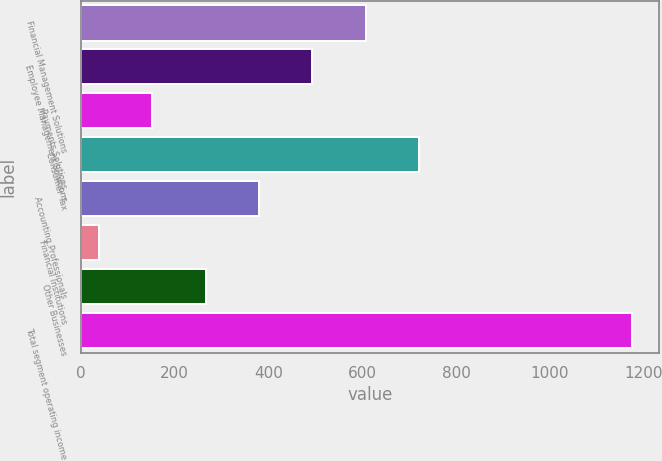<chart> <loc_0><loc_0><loc_500><loc_500><bar_chart><fcel>Financial Management Solutions<fcel>Employee Management Solutions<fcel>Payments Solutions<fcel>Consumer Tax<fcel>Accounting Professionals<fcel>Financial Institutions<fcel>Other Businesses<fcel>Total segment operating income<nl><fcel>606.85<fcel>493.24<fcel>152.41<fcel>720.46<fcel>379.63<fcel>38.8<fcel>266.02<fcel>1174.9<nl></chart> 